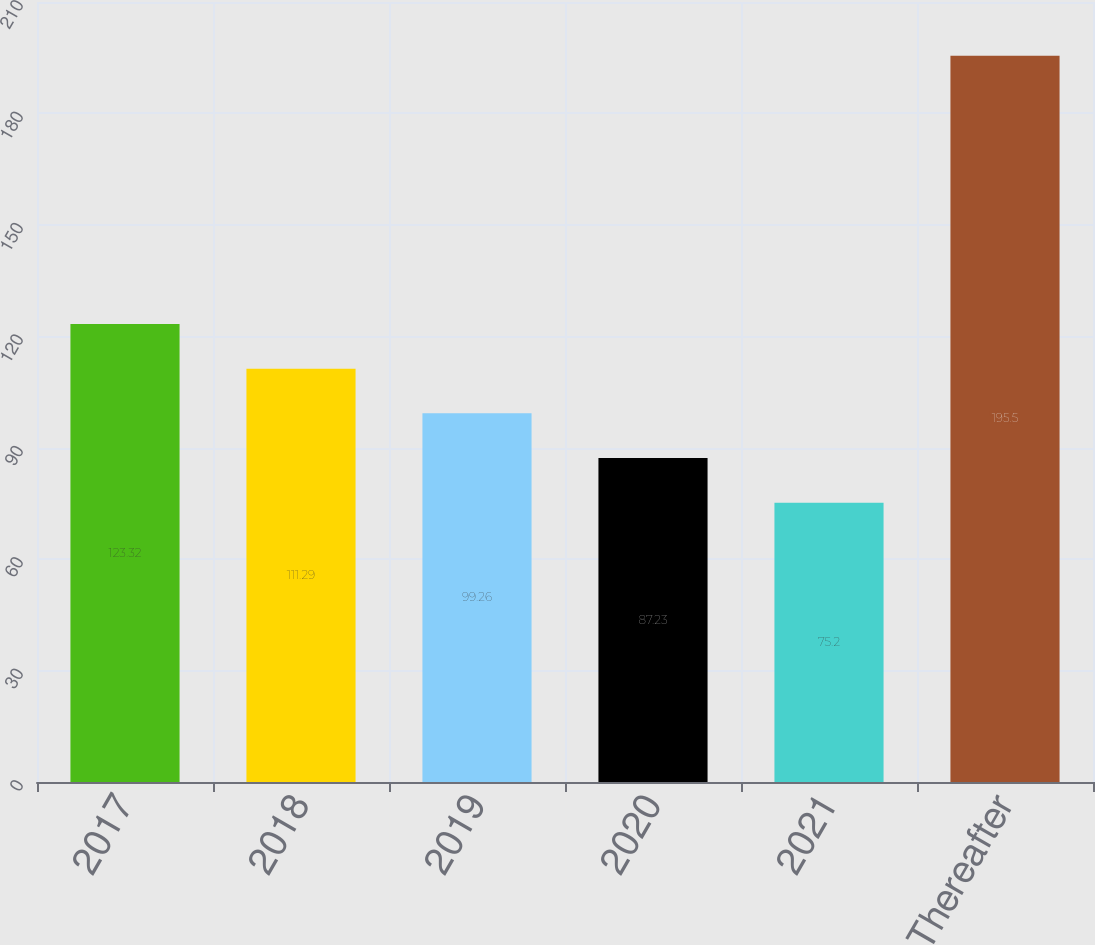Convert chart to OTSL. <chart><loc_0><loc_0><loc_500><loc_500><bar_chart><fcel>2017<fcel>2018<fcel>2019<fcel>2020<fcel>2021<fcel>Thereafter<nl><fcel>123.32<fcel>111.29<fcel>99.26<fcel>87.23<fcel>75.2<fcel>195.5<nl></chart> 